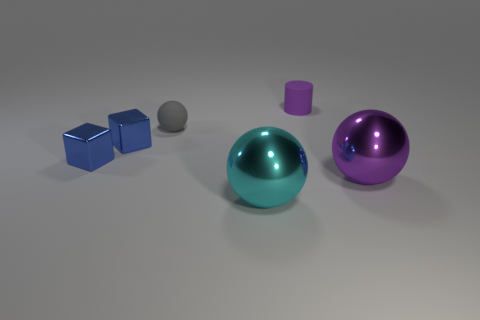Add 3 cyan rubber cylinders. How many objects exist? 9 Subtract all large spheres. How many spheres are left? 1 Subtract 1 cylinders. How many cylinders are left? 0 Subtract all cylinders. How many objects are left? 5 Add 3 blue shiny things. How many blue shiny things are left? 5 Add 4 small balls. How many small balls exist? 5 Subtract all cyan spheres. How many spheres are left? 2 Subtract 0 blue cylinders. How many objects are left? 6 Subtract all brown blocks. Subtract all purple cylinders. How many blocks are left? 2 Subtract all brown cylinders. How many red balls are left? 0 